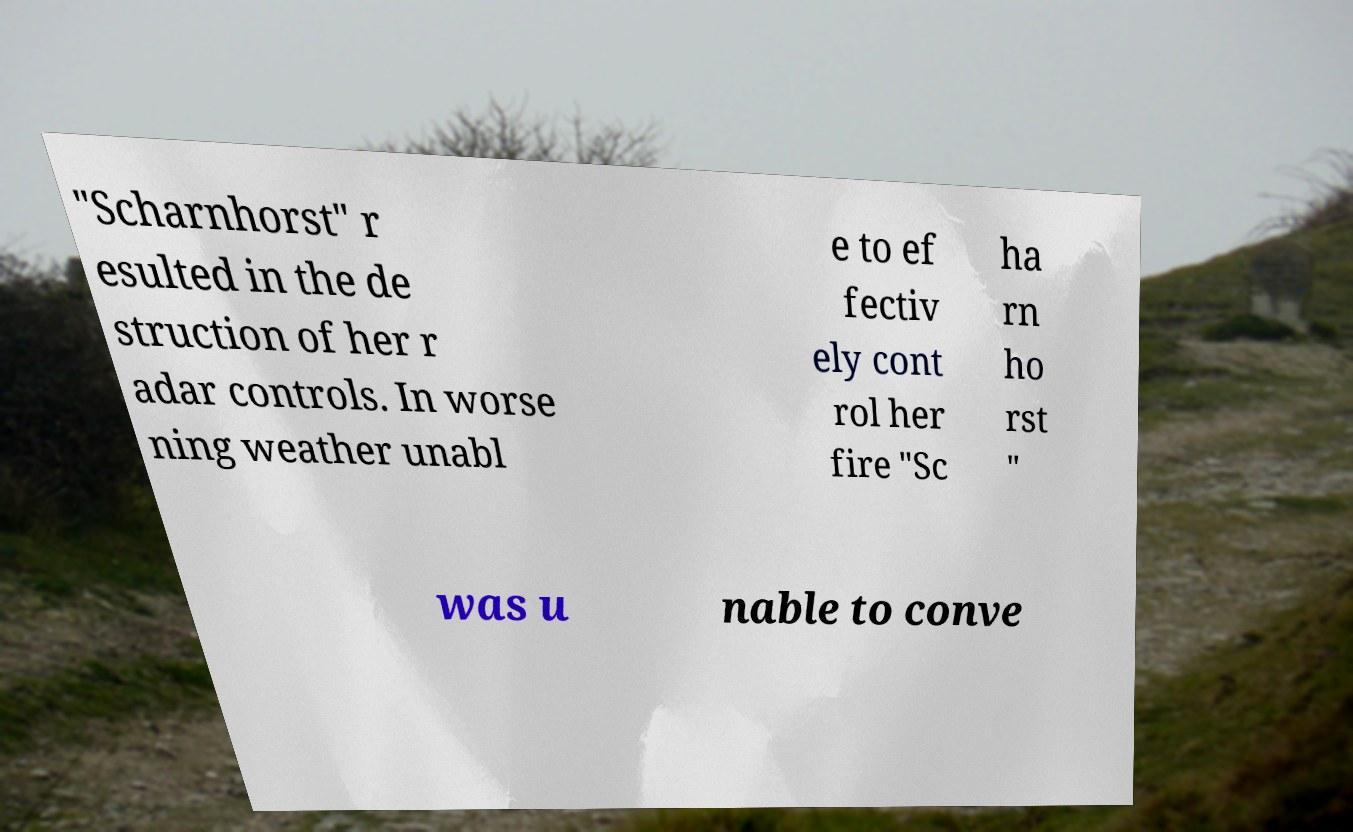Could you assist in decoding the text presented in this image and type it out clearly? "Scharnhorst" r esulted in the de struction of her r adar controls. In worse ning weather unabl e to ef fectiv ely cont rol her fire "Sc ha rn ho rst " was u nable to conve 